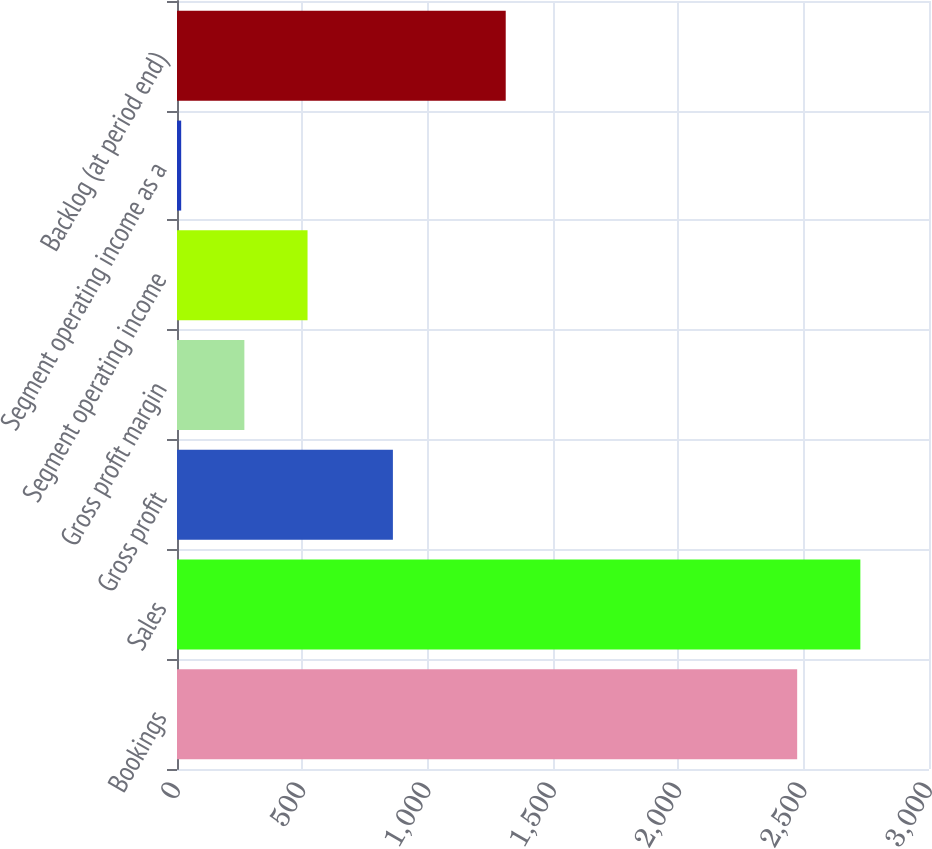Convert chart to OTSL. <chart><loc_0><loc_0><loc_500><loc_500><bar_chart><fcel>Bookings<fcel>Sales<fcel>Gross profit<fcel>Gross profit margin<fcel>Segment operating income<fcel>Segment operating income as a<fcel>Backlog (at period end)<nl><fcel>2474.1<fcel>2726.14<fcel>861.3<fcel>268.74<fcel>520.78<fcel>16.7<fcel>1311.4<nl></chart> 